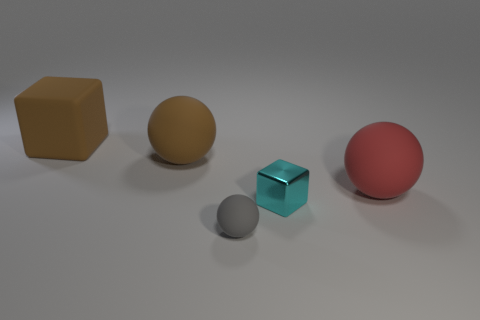The object that is to the left of the large rubber ball that is to the left of the block that is to the right of the large matte block is made of what material?
Your answer should be compact. Rubber. Is there a rubber ball that has the same size as the cyan metal thing?
Give a very brief answer. Yes. What is the material of the sphere that is the same size as the cyan block?
Your response must be concise. Rubber. There is a brown rubber object in front of the big block; what is its shape?
Your answer should be compact. Sphere. Do the big sphere right of the cyan metallic thing and the brown object that is right of the big block have the same material?
Your answer should be very brief. Yes. What number of tiny objects have the same shape as the large red matte thing?
Offer a terse response. 1. There is a big sphere that is the same color as the matte cube; what is it made of?
Keep it short and to the point. Rubber. How many objects are either cyan metallic blocks or brown matte objects that are left of the cyan block?
Make the answer very short. 3. What is the gray thing made of?
Offer a very short reply. Rubber. There is a red thing that is the same shape as the gray thing; what is its material?
Offer a very short reply. Rubber. 